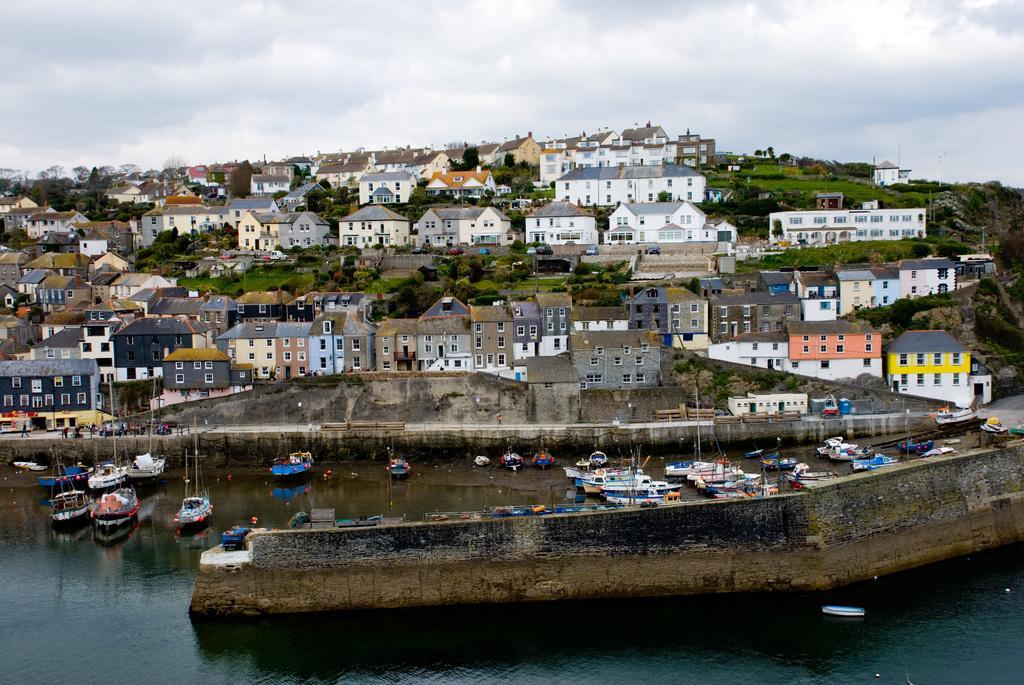Could you give a brief overview of what you see in this image? In this image I can see water in the front and on it I can see number of boats. In the background I can see number of buildings, number of trees, clouds and the sky. 